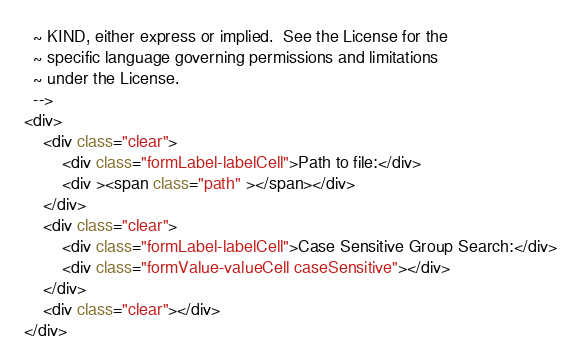<code> <loc_0><loc_0><loc_500><loc_500><_HTML_>  ~ KIND, either express or implied.  See the License for the
  ~ specific language governing permissions and limitations
  ~ under the License.
  -->
<div>
    <div class="clear">
        <div class="formLabel-labelCell">Path to file:</div>
        <div ><span class="path" ></span></div>
    </div>
    <div class="clear">
        <div class="formLabel-labelCell">Case Sensitive Group Search:</div>
        <div class="formValue-valueCell caseSensitive"></div>
    </div>
    <div class="clear"></div>
</div>
</code> 